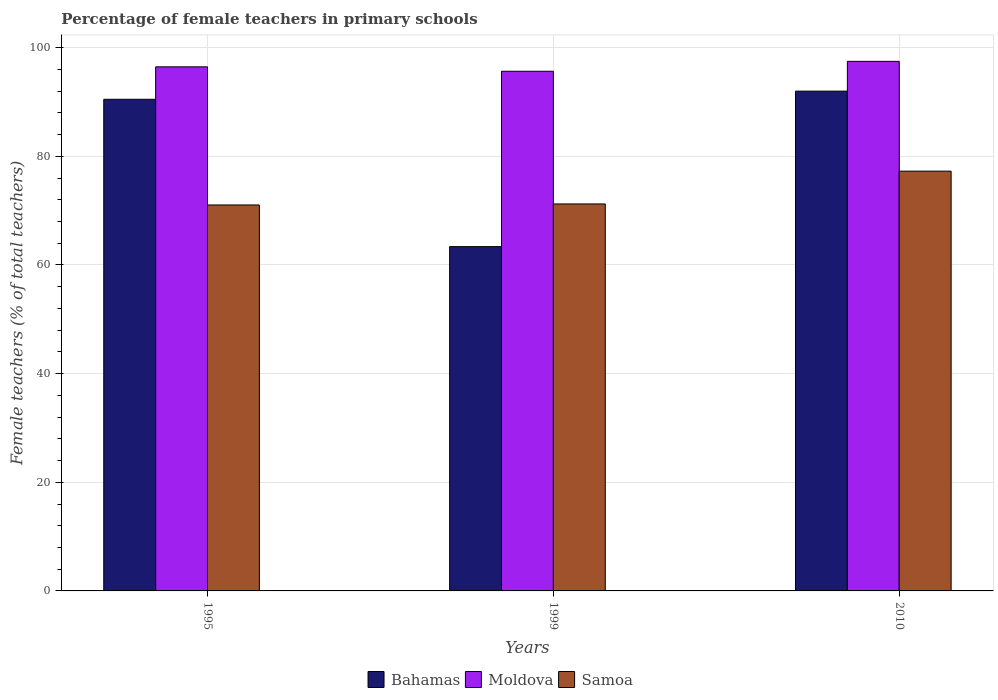Are the number of bars per tick equal to the number of legend labels?
Offer a very short reply. Yes. Are the number of bars on each tick of the X-axis equal?
Provide a succinct answer. Yes. How many bars are there on the 1st tick from the left?
Your answer should be very brief. 3. In how many cases, is the number of bars for a given year not equal to the number of legend labels?
Provide a succinct answer. 0. What is the percentage of female teachers in Bahamas in 1995?
Ensure brevity in your answer.  90.51. Across all years, what is the maximum percentage of female teachers in Bahamas?
Your answer should be compact. 92.01. Across all years, what is the minimum percentage of female teachers in Moldova?
Make the answer very short. 95.67. In which year was the percentage of female teachers in Bahamas maximum?
Your answer should be compact. 2010. What is the total percentage of female teachers in Moldova in the graph?
Offer a very short reply. 289.63. What is the difference between the percentage of female teachers in Bahamas in 1995 and that in 1999?
Give a very brief answer. 27.12. What is the difference between the percentage of female teachers in Moldova in 1999 and the percentage of female teachers in Bahamas in 1995?
Keep it short and to the point. 5.16. What is the average percentage of female teachers in Moldova per year?
Offer a very short reply. 96.54. In the year 2010, what is the difference between the percentage of female teachers in Bahamas and percentage of female teachers in Moldova?
Your response must be concise. -5.48. What is the ratio of the percentage of female teachers in Moldova in 1995 to that in 2010?
Ensure brevity in your answer.  0.99. Is the percentage of female teachers in Samoa in 1999 less than that in 2010?
Offer a very short reply. Yes. Is the difference between the percentage of female teachers in Bahamas in 1999 and 2010 greater than the difference between the percentage of female teachers in Moldova in 1999 and 2010?
Provide a succinct answer. No. What is the difference between the highest and the second highest percentage of female teachers in Moldova?
Give a very brief answer. 1.01. What is the difference between the highest and the lowest percentage of female teachers in Samoa?
Keep it short and to the point. 6.23. Is the sum of the percentage of female teachers in Bahamas in 1999 and 2010 greater than the maximum percentage of female teachers in Samoa across all years?
Ensure brevity in your answer.  Yes. What does the 2nd bar from the left in 2010 represents?
Your answer should be very brief. Moldova. What does the 3rd bar from the right in 2010 represents?
Keep it short and to the point. Bahamas. Is it the case that in every year, the sum of the percentage of female teachers in Moldova and percentage of female teachers in Bahamas is greater than the percentage of female teachers in Samoa?
Give a very brief answer. Yes. How many bars are there?
Keep it short and to the point. 9. How many years are there in the graph?
Your answer should be compact. 3. What is the difference between two consecutive major ticks on the Y-axis?
Keep it short and to the point. 20. Where does the legend appear in the graph?
Offer a terse response. Bottom center. How are the legend labels stacked?
Keep it short and to the point. Horizontal. What is the title of the graph?
Your answer should be very brief. Percentage of female teachers in primary schools. What is the label or title of the X-axis?
Ensure brevity in your answer.  Years. What is the label or title of the Y-axis?
Make the answer very short. Female teachers (% of total teachers). What is the Female teachers (% of total teachers) of Bahamas in 1995?
Your answer should be very brief. 90.51. What is the Female teachers (% of total teachers) in Moldova in 1995?
Your answer should be very brief. 96.48. What is the Female teachers (% of total teachers) of Samoa in 1995?
Make the answer very short. 71.05. What is the Female teachers (% of total teachers) in Bahamas in 1999?
Your answer should be very brief. 63.38. What is the Female teachers (% of total teachers) in Moldova in 1999?
Your answer should be very brief. 95.67. What is the Female teachers (% of total teachers) in Samoa in 1999?
Make the answer very short. 71.24. What is the Female teachers (% of total teachers) of Bahamas in 2010?
Your answer should be very brief. 92.01. What is the Female teachers (% of total teachers) of Moldova in 2010?
Offer a terse response. 97.49. What is the Female teachers (% of total teachers) in Samoa in 2010?
Provide a short and direct response. 77.28. Across all years, what is the maximum Female teachers (% of total teachers) in Bahamas?
Your answer should be very brief. 92.01. Across all years, what is the maximum Female teachers (% of total teachers) in Moldova?
Make the answer very short. 97.49. Across all years, what is the maximum Female teachers (% of total teachers) in Samoa?
Keep it short and to the point. 77.28. Across all years, what is the minimum Female teachers (% of total teachers) in Bahamas?
Make the answer very short. 63.38. Across all years, what is the minimum Female teachers (% of total teachers) of Moldova?
Your answer should be very brief. 95.67. Across all years, what is the minimum Female teachers (% of total teachers) of Samoa?
Keep it short and to the point. 71.05. What is the total Female teachers (% of total teachers) in Bahamas in the graph?
Your answer should be very brief. 245.89. What is the total Female teachers (% of total teachers) in Moldova in the graph?
Your response must be concise. 289.63. What is the total Female teachers (% of total teachers) of Samoa in the graph?
Make the answer very short. 219.57. What is the difference between the Female teachers (% of total teachers) of Bahamas in 1995 and that in 1999?
Your answer should be compact. 27.12. What is the difference between the Female teachers (% of total teachers) of Moldova in 1995 and that in 1999?
Give a very brief answer. 0.81. What is the difference between the Female teachers (% of total teachers) in Samoa in 1995 and that in 1999?
Provide a short and direct response. -0.19. What is the difference between the Female teachers (% of total teachers) of Bahamas in 1995 and that in 2010?
Give a very brief answer. -1.5. What is the difference between the Female teachers (% of total teachers) of Moldova in 1995 and that in 2010?
Offer a terse response. -1.01. What is the difference between the Female teachers (% of total teachers) in Samoa in 1995 and that in 2010?
Offer a terse response. -6.23. What is the difference between the Female teachers (% of total teachers) of Bahamas in 1999 and that in 2010?
Your answer should be compact. -28.62. What is the difference between the Female teachers (% of total teachers) of Moldova in 1999 and that in 2010?
Give a very brief answer. -1.82. What is the difference between the Female teachers (% of total teachers) in Samoa in 1999 and that in 2010?
Ensure brevity in your answer.  -6.04. What is the difference between the Female teachers (% of total teachers) of Bahamas in 1995 and the Female teachers (% of total teachers) of Moldova in 1999?
Your response must be concise. -5.16. What is the difference between the Female teachers (% of total teachers) in Bahamas in 1995 and the Female teachers (% of total teachers) in Samoa in 1999?
Provide a short and direct response. 19.26. What is the difference between the Female teachers (% of total teachers) of Moldova in 1995 and the Female teachers (% of total teachers) of Samoa in 1999?
Your response must be concise. 25.24. What is the difference between the Female teachers (% of total teachers) in Bahamas in 1995 and the Female teachers (% of total teachers) in Moldova in 2010?
Your answer should be compact. -6.98. What is the difference between the Female teachers (% of total teachers) of Bahamas in 1995 and the Female teachers (% of total teachers) of Samoa in 2010?
Your answer should be very brief. 13.23. What is the difference between the Female teachers (% of total teachers) in Moldova in 1995 and the Female teachers (% of total teachers) in Samoa in 2010?
Offer a very short reply. 19.2. What is the difference between the Female teachers (% of total teachers) in Bahamas in 1999 and the Female teachers (% of total teachers) in Moldova in 2010?
Keep it short and to the point. -34.11. What is the difference between the Female teachers (% of total teachers) of Bahamas in 1999 and the Female teachers (% of total teachers) of Samoa in 2010?
Your response must be concise. -13.89. What is the difference between the Female teachers (% of total teachers) of Moldova in 1999 and the Female teachers (% of total teachers) of Samoa in 2010?
Offer a very short reply. 18.39. What is the average Female teachers (% of total teachers) in Bahamas per year?
Offer a very short reply. 81.97. What is the average Female teachers (% of total teachers) of Moldova per year?
Ensure brevity in your answer.  96.54. What is the average Female teachers (% of total teachers) in Samoa per year?
Offer a terse response. 73.19. In the year 1995, what is the difference between the Female teachers (% of total teachers) in Bahamas and Female teachers (% of total teachers) in Moldova?
Make the answer very short. -5.97. In the year 1995, what is the difference between the Female teachers (% of total teachers) of Bahamas and Female teachers (% of total teachers) of Samoa?
Your answer should be compact. 19.45. In the year 1995, what is the difference between the Female teachers (% of total teachers) in Moldova and Female teachers (% of total teachers) in Samoa?
Offer a terse response. 25.43. In the year 1999, what is the difference between the Female teachers (% of total teachers) in Bahamas and Female teachers (% of total teachers) in Moldova?
Keep it short and to the point. -32.28. In the year 1999, what is the difference between the Female teachers (% of total teachers) of Bahamas and Female teachers (% of total teachers) of Samoa?
Make the answer very short. -7.86. In the year 1999, what is the difference between the Female teachers (% of total teachers) in Moldova and Female teachers (% of total teachers) in Samoa?
Offer a terse response. 24.43. In the year 2010, what is the difference between the Female teachers (% of total teachers) of Bahamas and Female teachers (% of total teachers) of Moldova?
Keep it short and to the point. -5.48. In the year 2010, what is the difference between the Female teachers (% of total teachers) in Bahamas and Female teachers (% of total teachers) in Samoa?
Provide a short and direct response. 14.73. In the year 2010, what is the difference between the Female teachers (% of total teachers) in Moldova and Female teachers (% of total teachers) in Samoa?
Make the answer very short. 20.21. What is the ratio of the Female teachers (% of total teachers) of Bahamas in 1995 to that in 1999?
Offer a very short reply. 1.43. What is the ratio of the Female teachers (% of total teachers) of Moldova in 1995 to that in 1999?
Your answer should be compact. 1.01. What is the ratio of the Female teachers (% of total teachers) of Bahamas in 1995 to that in 2010?
Your answer should be compact. 0.98. What is the ratio of the Female teachers (% of total teachers) in Moldova in 1995 to that in 2010?
Provide a short and direct response. 0.99. What is the ratio of the Female teachers (% of total teachers) in Samoa in 1995 to that in 2010?
Offer a very short reply. 0.92. What is the ratio of the Female teachers (% of total teachers) in Bahamas in 1999 to that in 2010?
Give a very brief answer. 0.69. What is the ratio of the Female teachers (% of total teachers) of Moldova in 1999 to that in 2010?
Provide a succinct answer. 0.98. What is the ratio of the Female teachers (% of total teachers) of Samoa in 1999 to that in 2010?
Offer a terse response. 0.92. What is the difference between the highest and the second highest Female teachers (% of total teachers) in Bahamas?
Your response must be concise. 1.5. What is the difference between the highest and the second highest Female teachers (% of total teachers) of Moldova?
Your answer should be compact. 1.01. What is the difference between the highest and the second highest Female teachers (% of total teachers) in Samoa?
Offer a very short reply. 6.04. What is the difference between the highest and the lowest Female teachers (% of total teachers) in Bahamas?
Make the answer very short. 28.62. What is the difference between the highest and the lowest Female teachers (% of total teachers) of Moldova?
Your answer should be very brief. 1.82. What is the difference between the highest and the lowest Female teachers (% of total teachers) of Samoa?
Ensure brevity in your answer.  6.23. 